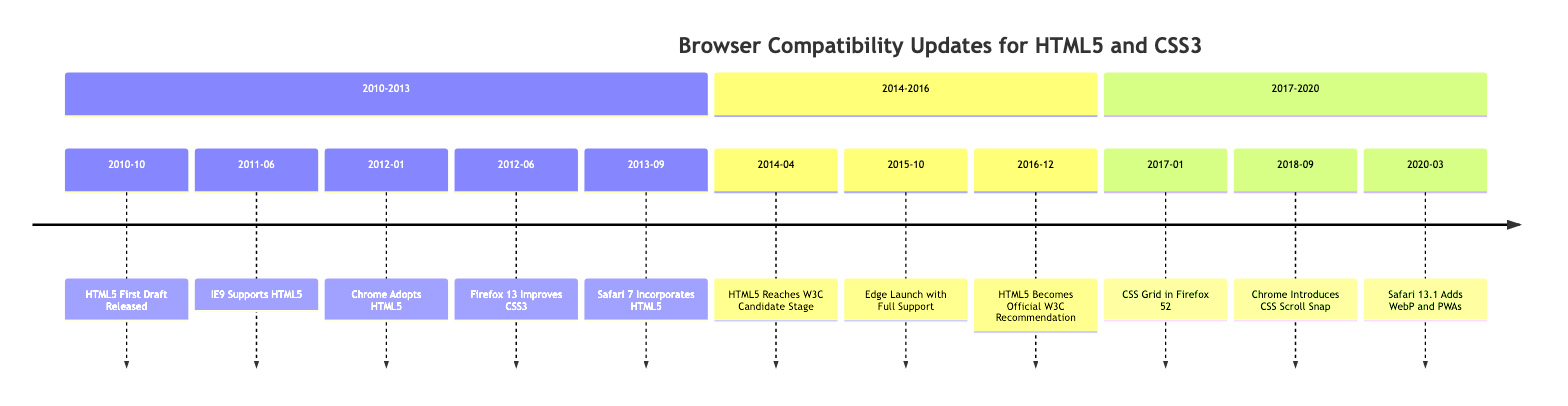What event marked the beginning of HTML5's wider industry adoption? The timeline shows "HTML5 First Draft Released" in October 2010, which is the event marking the start of HTML5's wider adoption.
Answer: HTML5 First Draft Released Which browser was the first to support HTML5 and CSS3 significantly? According to the timeline, Internet Explorer 9, released in June 2011, was the browser that introduced significant support for HTML5 and CSS3.
Answer: Internet Explorer 9 How many events are listed within the 2014-2016 section of the timeline? The section 2014-2016 contains three events: HTML5 Reaches W3C Candidate Stage, Edge Launch with Full Support, and HTML5 Becomes Official W3C Recommendation, so there are three events listed.
Answer: 3 What feature did Firefox 52 introduce in January 2017? The timeline indicates that Mozilla Firefox 52 introduced CSS Grid Layout in January 2017, which is the feature in question.
Answer: CSS Grid Layout Which browser launched in October 2015 with full HTML5 and CSS3 support? The timeline specifies that Microsoft launched the Edge browser in October 2015, designed to fully support HTML5 and CSS3.
Answer: Edge What significant milestone did HTML5 achieve in December 2016? The timeline notes that HTML5 became an official W3C Recommendation in December 2016, which marks a significant milestone in its history.
Answer: Official W3C Recommendation Which CSS feature was introduced by Chrome in September 2018? The timeline reveals that Chrome introduced CSS Scroll Snap in September 2018 as a new feature.
Answer: CSS Scroll Snap What does the timeline suggest about the progression of browser support for HTML5? By reviewing the timeline, it shows a clear trend of increasing support for HTML5 and CSS3 across major browsers over the years, culminating in official recommendations and widespread implementation.
Answer: Increasing support across browsers How many years passed between HTML5's first draft release and its official W3C Recommendation? The timeline indicates that HTML5's first draft was released in October 2010 and became an official recommendation in December 2016, which totals over six years.
Answer: 6 years 